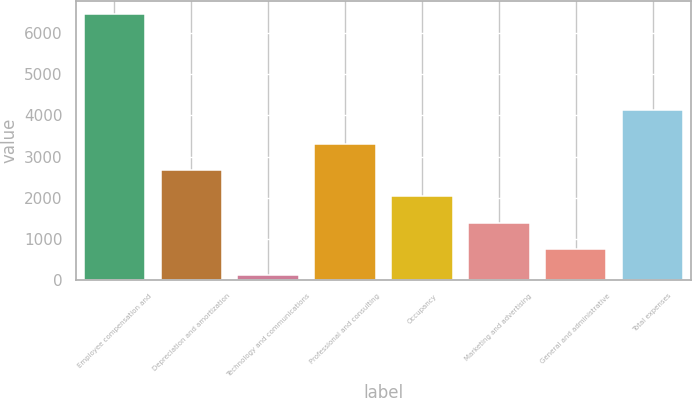Convert chart. <chart><loc_0><loc_0><loc_500><loc_500><bar_chart><fcel>Employee compensation and<fcel>Depreciation and amortization<fcel>Technology and communications<fcel>Professional and consulting<fcel>Occupancy<fcel>Marketing and advertising<fcel>General and administrative<fcel>Total expenses<nl><fcel>6464<fcel>2660.6<fcel>125<fcel>3294.5<fcel>2026.7<fcel>1392.8<fcel>758.9<fcel>4139<nl></chart> 